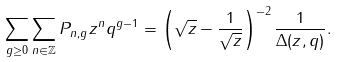<formula> <loc_0><loc_0><loc_500><loc_500>\sum _ { g \geq 0 } \sum _ { n \in \mathbb { Z } } P _ { n , g } z ^ { n } q ^ { g - 1 } = \left ( \sqrt { z } - \frac { 1 } { \sqrt { z } } \right ) ^ { - 2 } \frac { 1 } { \Delta ( z , q ) } .</formula> 